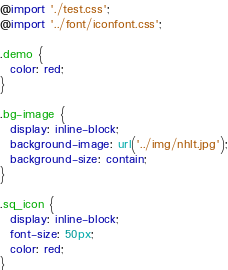<code> <loc_0><loc_0><loc_500><loc_500><_CSS_>@import './test.css';
@import '../font/iconfont.css';

.demo {
  color: red;
}

.bg-image {
  display: inline-block;
  background-image: url('../img/nhlt.jpg');
  background-size: contain;
}

.sq_icon {
  display: inline-block;
  font-size: 50px;
  color: red;
}</code> 